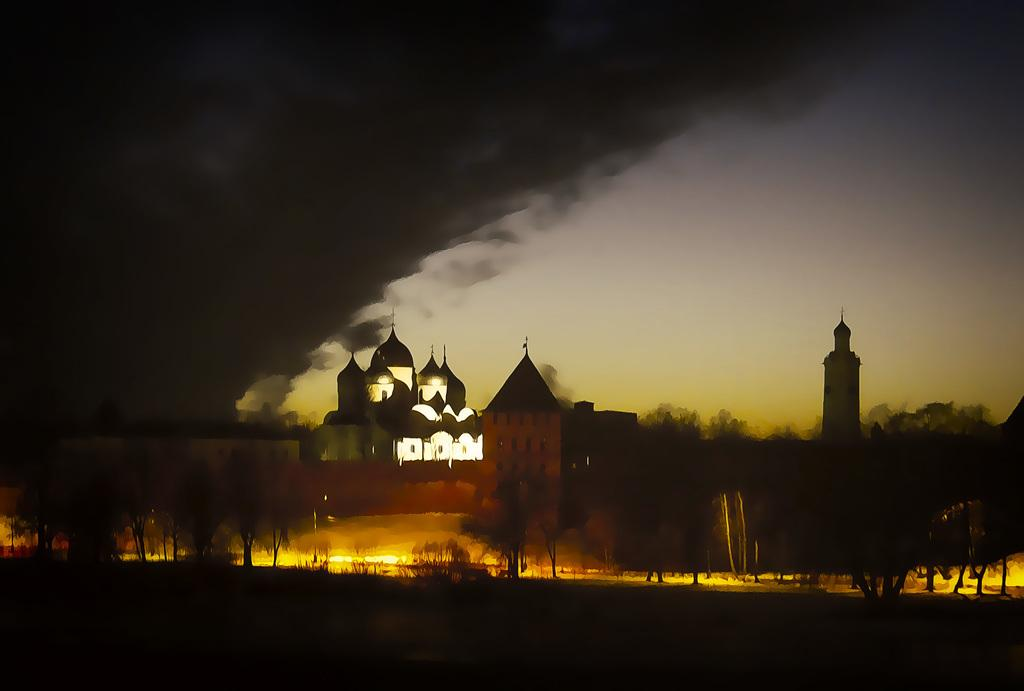What type of natural elements are in the middle of the image? There are trees in the middle of the image. What type of man-made structures are visible in the image? There are buildings with lights in the image. What can be seen on the left side of the image? There appears to be smoke on the left side of the image. What is visible at the top of the image? The sky is visible at the top of the image. What unit of measurement is used to describe the love shown in the image? There is no love present in the image, so there is no unit of measurement to describe it. Can you provide an example of a building with lights in the image? There is no need to provide an example, as the fact states that there are buildings with lights in the image. 